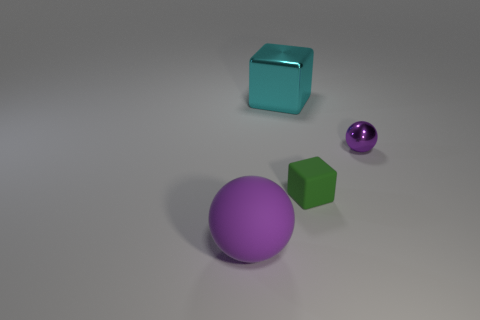Add 3 shiny balls. How many objects exist? 7 Subtract 0 brown cylinders. How many objects are left? 4 Subtract all matte things. Subtract all big things. How many objects are left? 0 Add 4 small green matte things. How many small green matte things are left? 5 Add 1 small red metallic objects. How many small red metallic objects exist? 1 